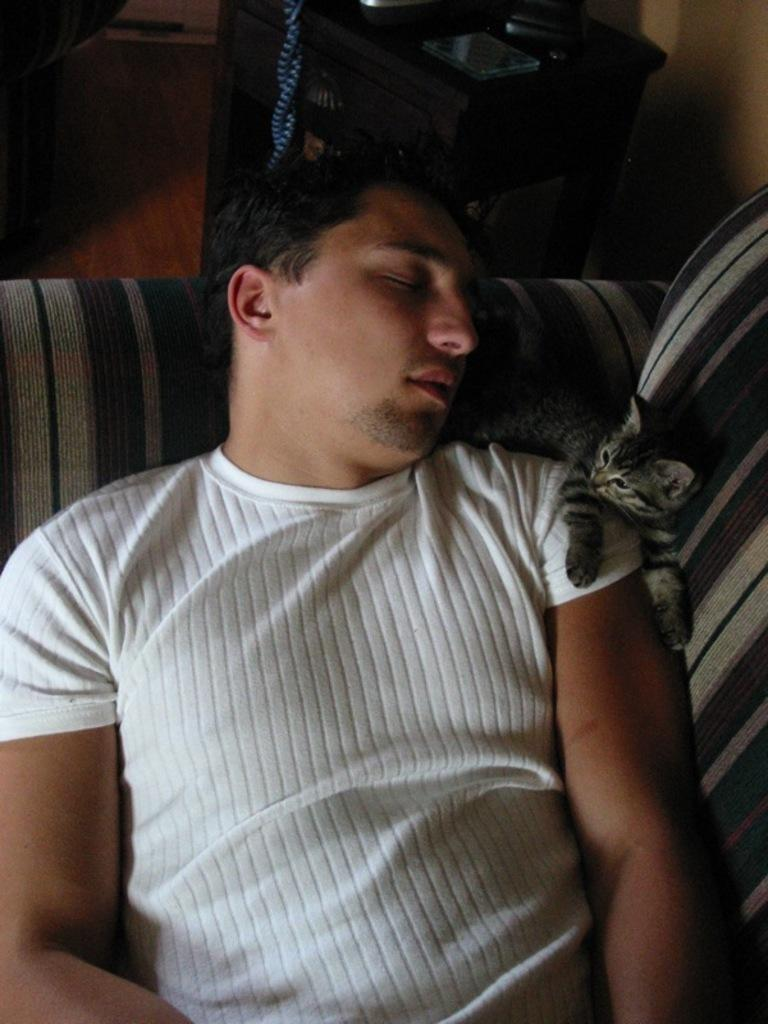What is the man in the image doing? The man is sleeping in a couch. What type of animal is present in the image? There is a cat in the image. What piece of furniture is visible in the image? There is a table in the image. What object related to reading can be seen in the image? There is a book in the image. What type of cakes are being served on the wire in the image? There is no wire or cakes present in the image. 